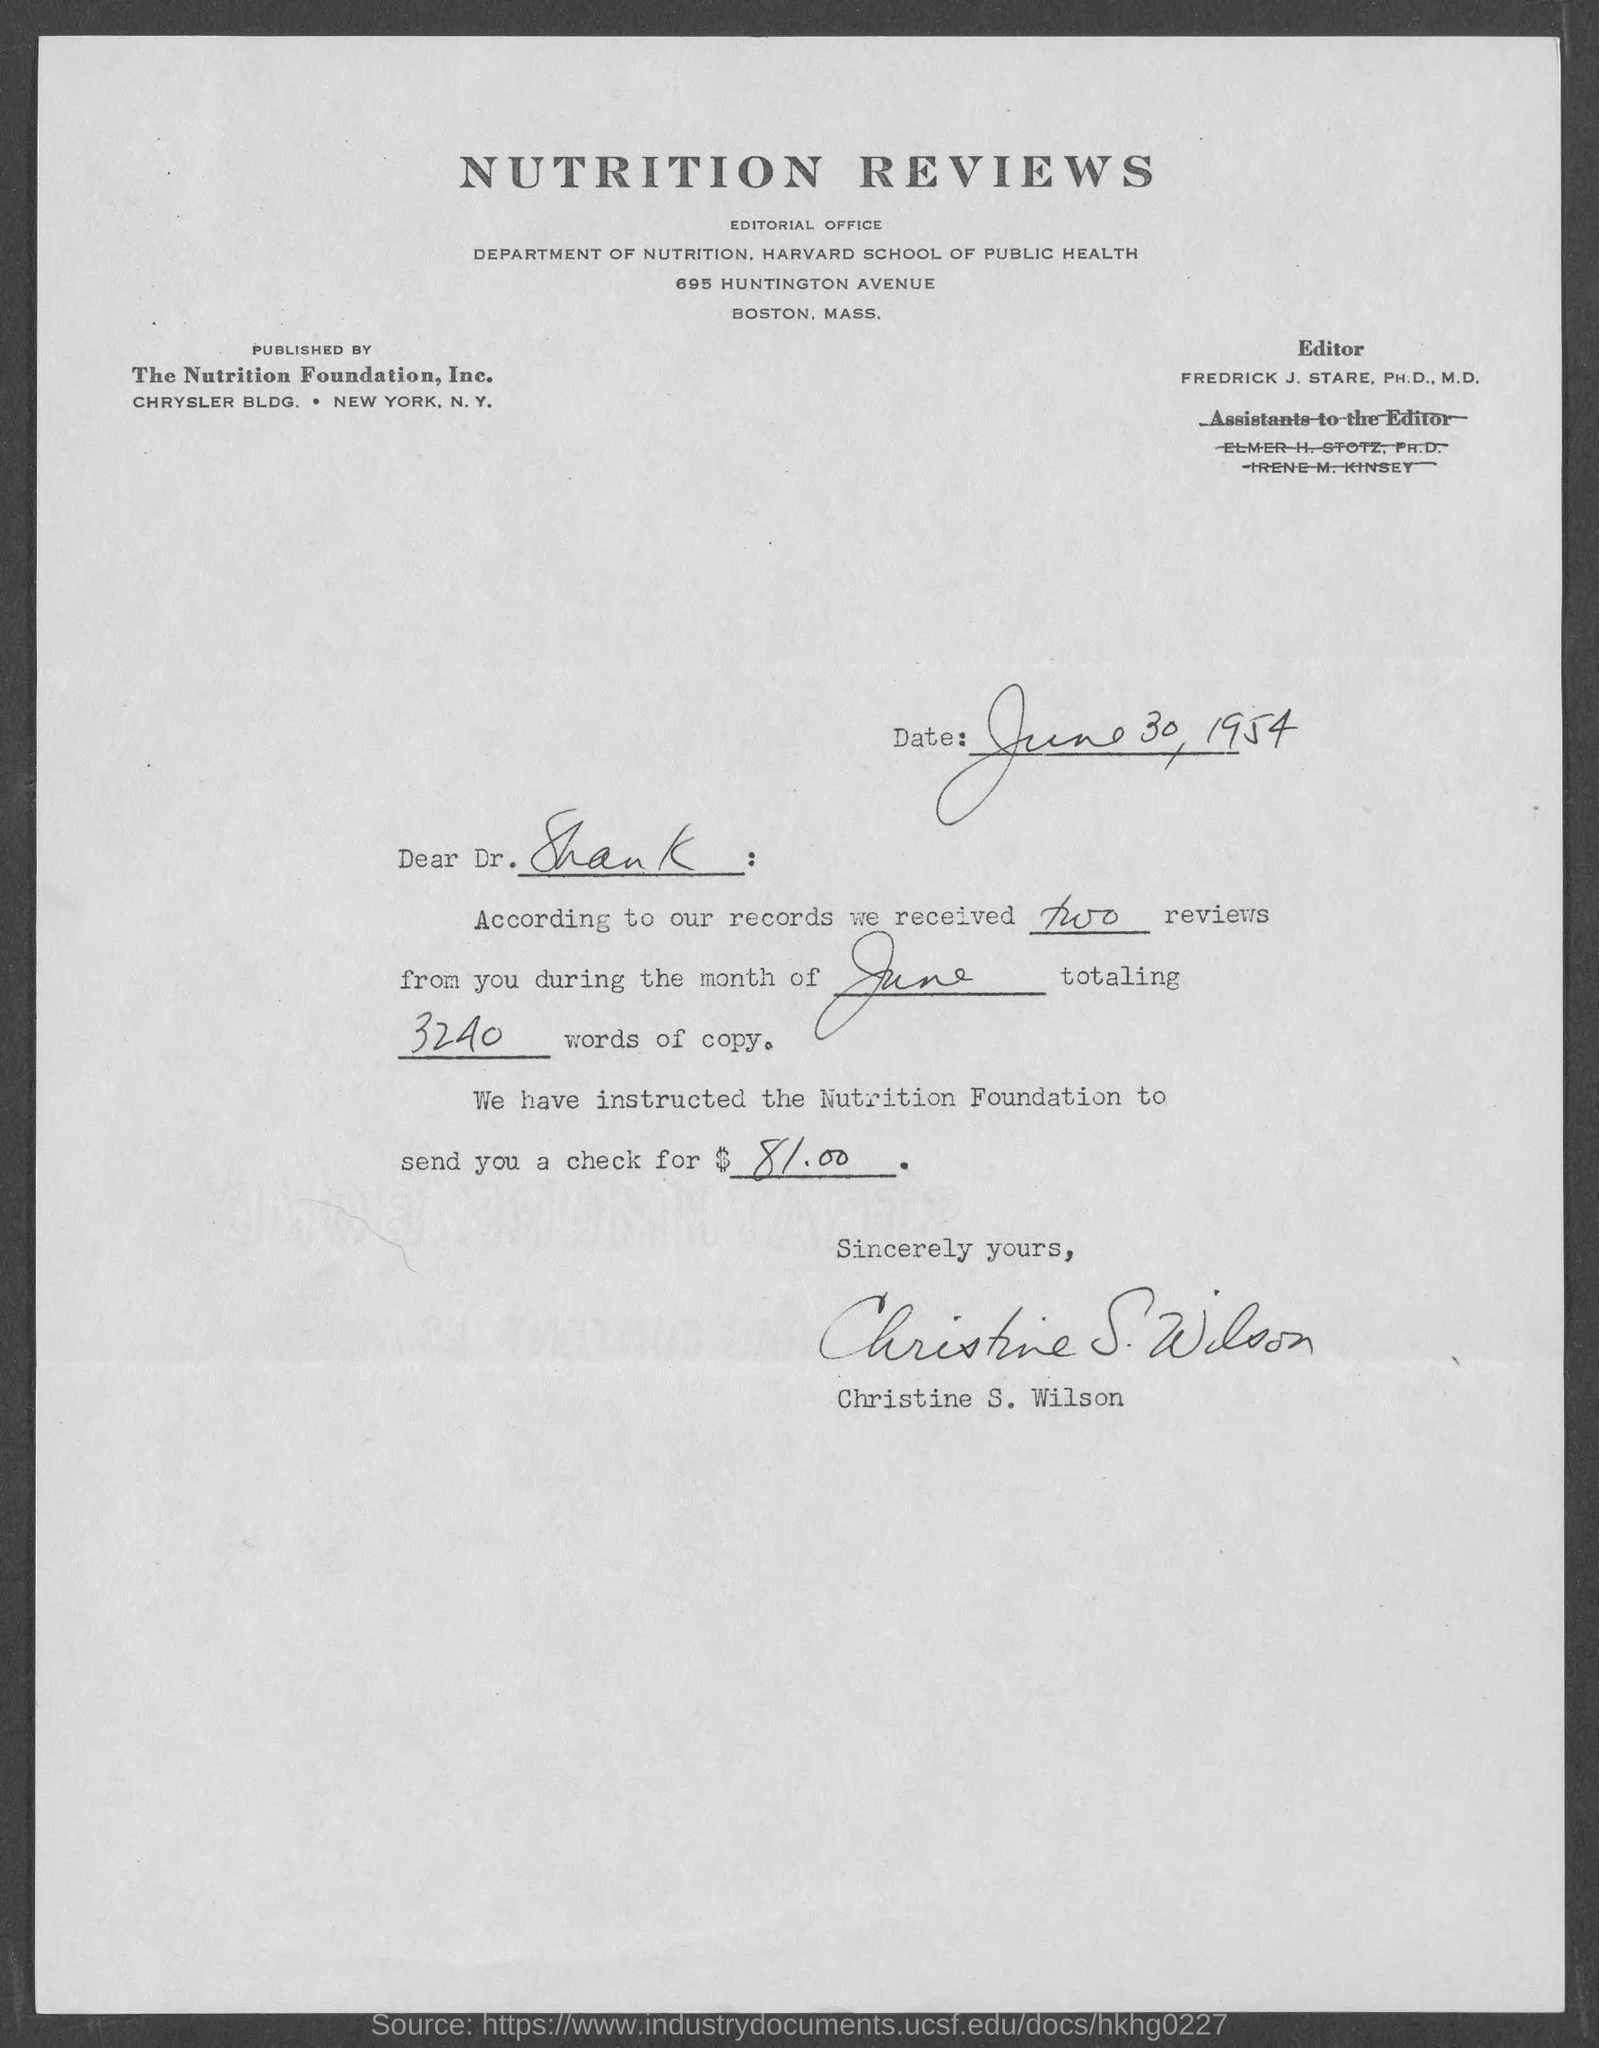Indicate a few pertinent items in this graphic. The sign at the end of the letter was that of Christine S. Wilson. The date mentioned on the given page is June 30, 1954. The letter was written to Dr. Shank. The reviews were received during the month mentioned in the given letter, which was June. The name of the editor mentioned in the given page is Fredrick J. Stare. 